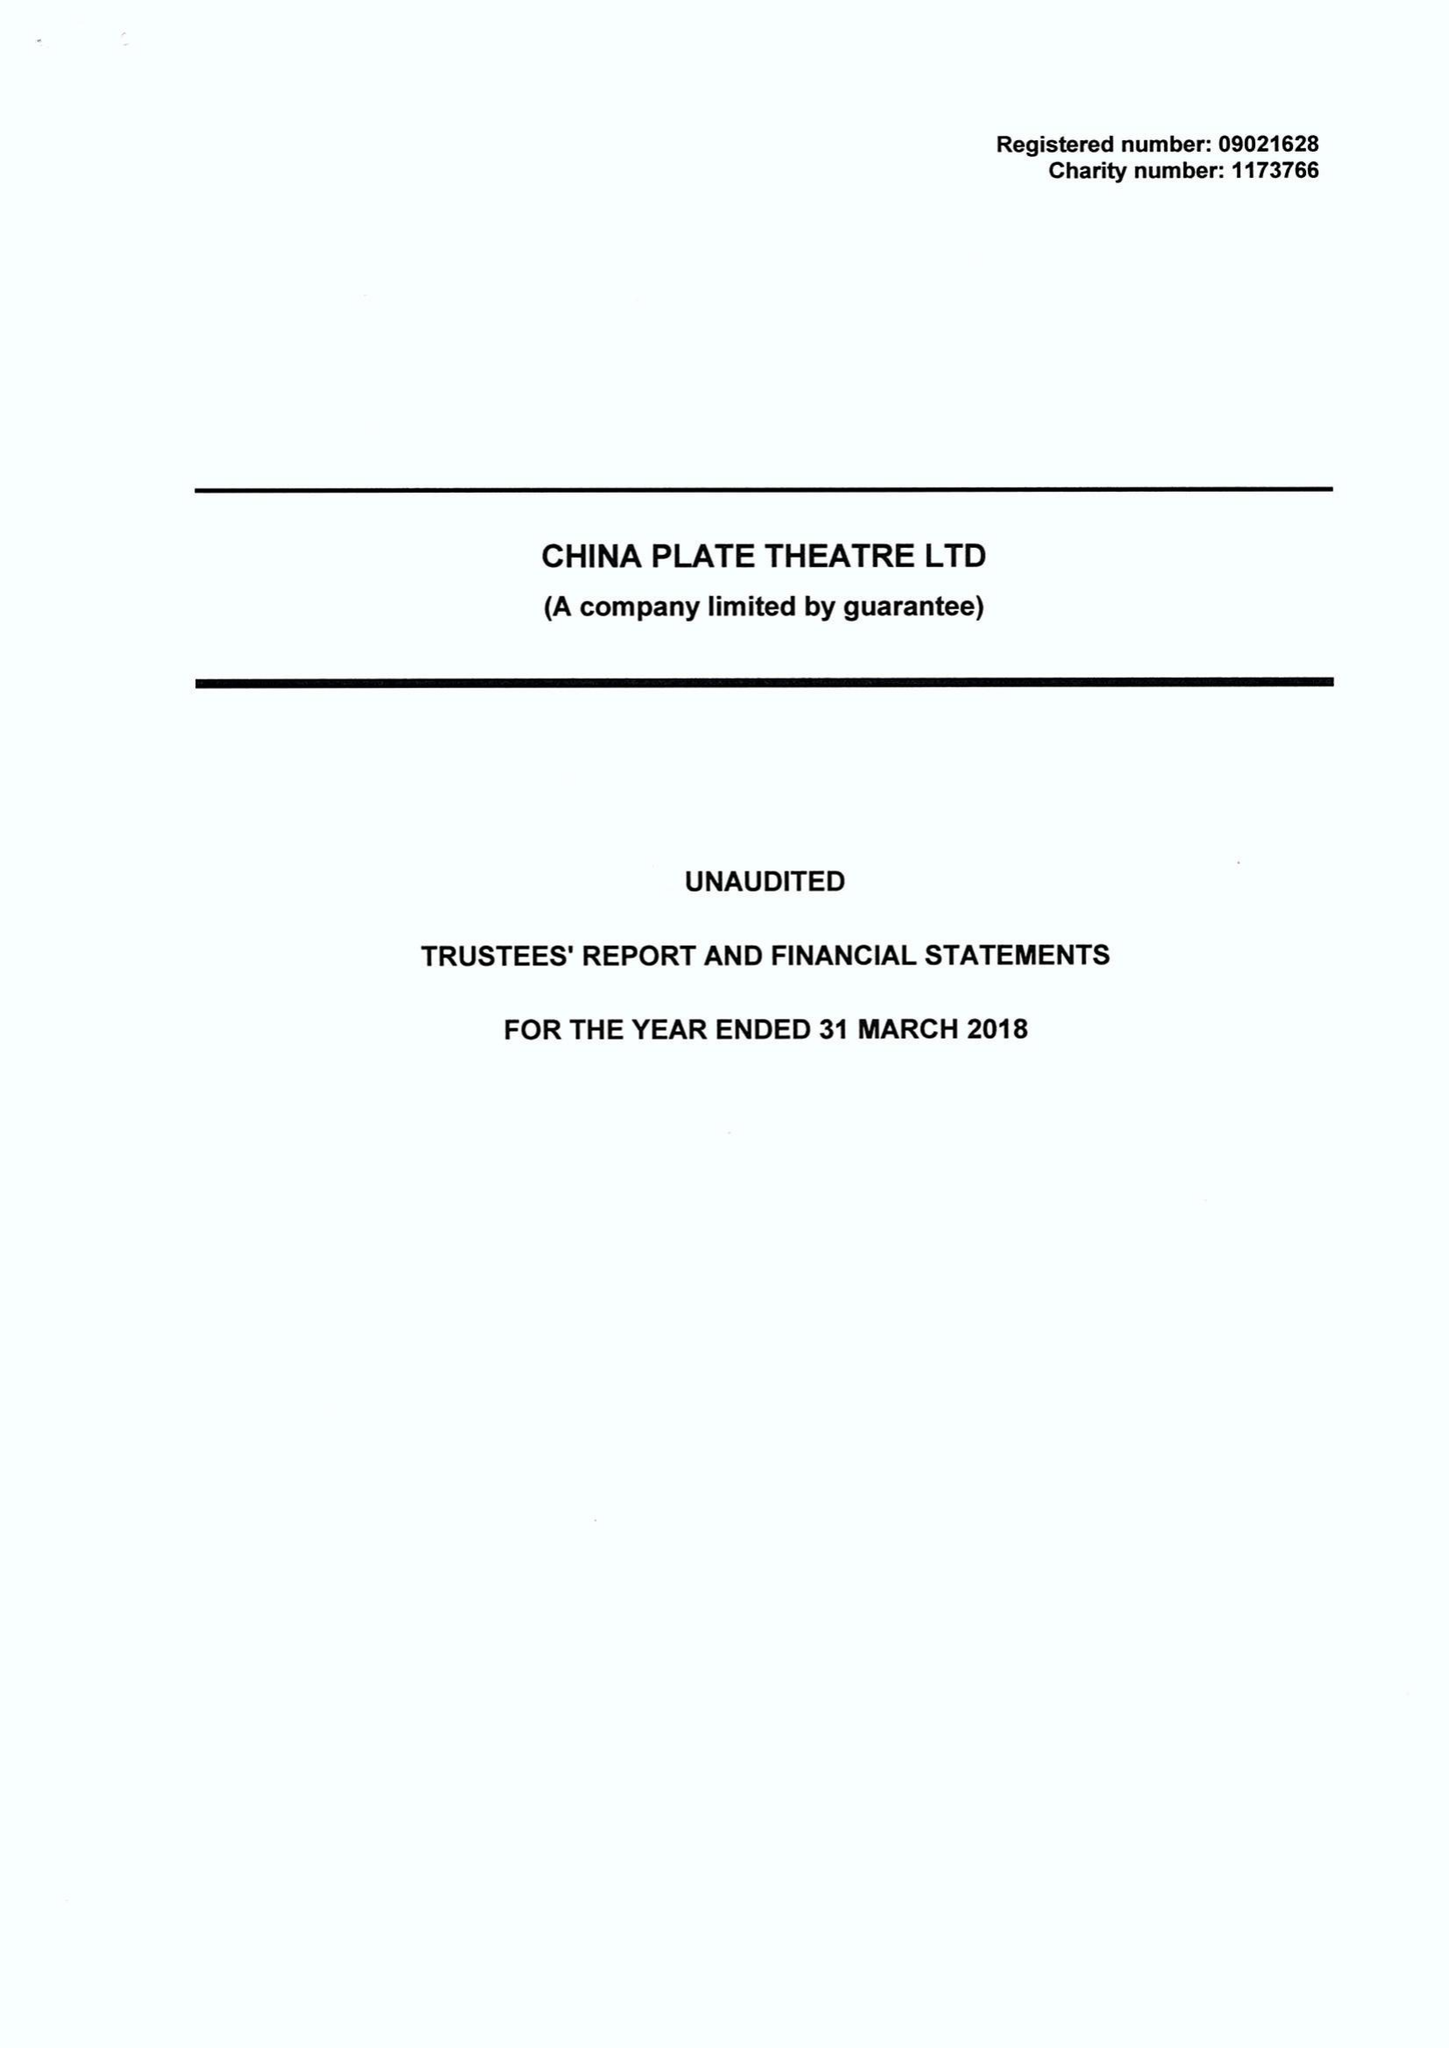What is the value for the address__street_line?
Answer the question using a single word or phrase. 180-182 FAZELEY STREET 